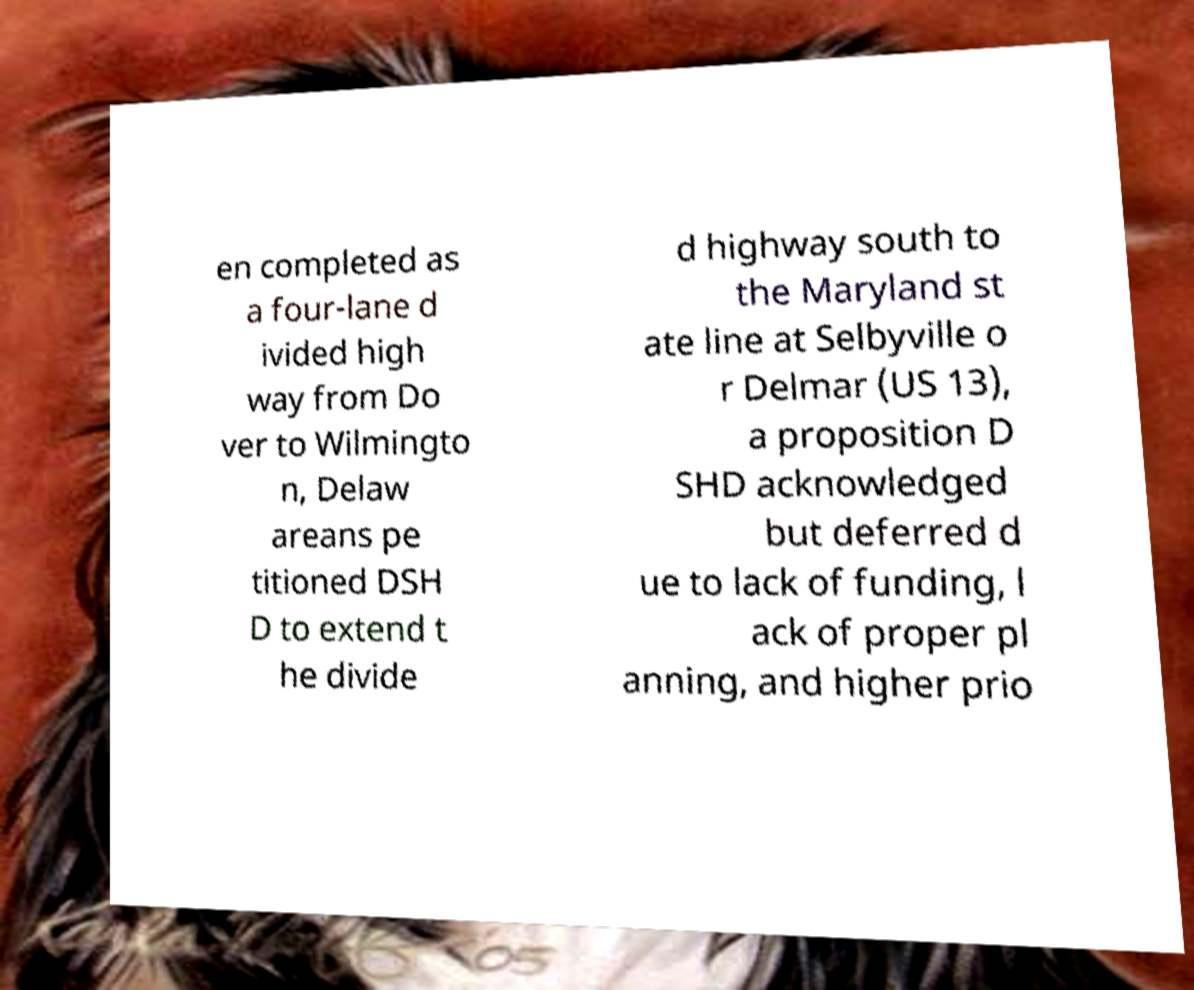Can you read and provide the text displayed in the image?This photo seems to have some interesting text. Can you extract and type it out for me? en completed as a four-lane d ivided high way from Do ver to Wilmingto n, Delaw areans pe titioned DSH D to extend t he divide d highway south to the Maryland st ate line at Selbyville o r Delmar (US 13), a proposition D SHD acknowledged but deferred d ue to lack of funding, l ack of proper pl anning, and higher prio 